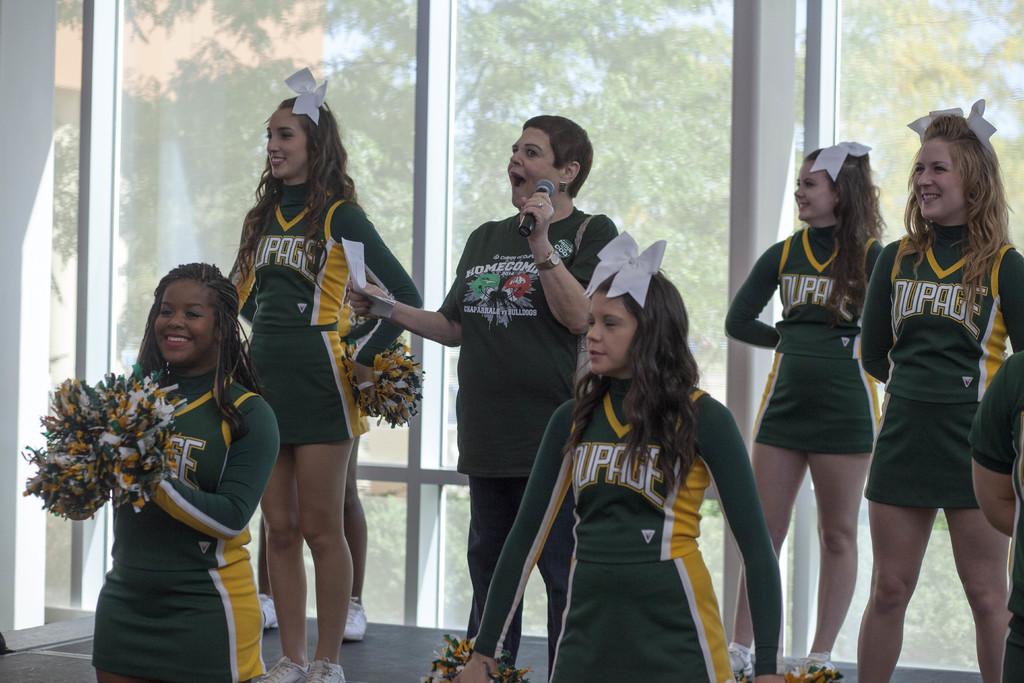What event is the woman with the microphone excited about?
Offer a terse response. Homecoming. 